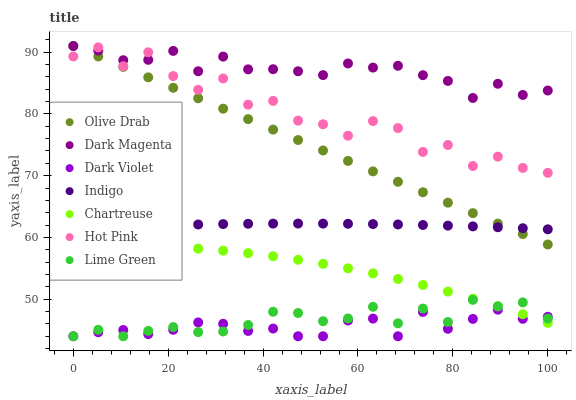Does Dark Violet have the minimum area under the curve?
Answer yes or no. Yes. Does Dark Magenta have the maximum area under the curve?
Answer yes or no. Yes. Does Hot Pink have the minimum area under the curve?
Answer yes or no. No. Does Hot Pink have the maximum area under the curve?
Answer yes or no. No. Is Olive Drab the smoothest?
Answer yes or no. Yes. Is Hot Pink the roughest?
Answer yes or no. Yes. Is Dark Magenta the smoothest?
Answer yes or no. No. Is Dark Magenta the roughest?
Answer yes or no. No. Does Dark Violet have the lowest value?
Answer yes or no. Yes. Does Hot Pink have the lowest value?
Answer yes or no. No. Does Olive Drab have the highest value?
Answer yes or no. Yes. Does Hot Pink have the highest value?
Answer yes or no. No. Is Lime Green less than Olive Drab?
Answer yes or no. Yes. Is Hot Pink greater than Indigo?
Answer yes or no. Yes. Does Dark Magenta intersect Hot Pink?
Answer yes or no. Yes. Is Dark Magenta less than Hot Pink?
Answer yes or no. No. Is Dark Magenta greater than Hot Pink?
Answer yes or no. No. Does Lime Green intersect Olive Drab?
Answer yes or no. No. 